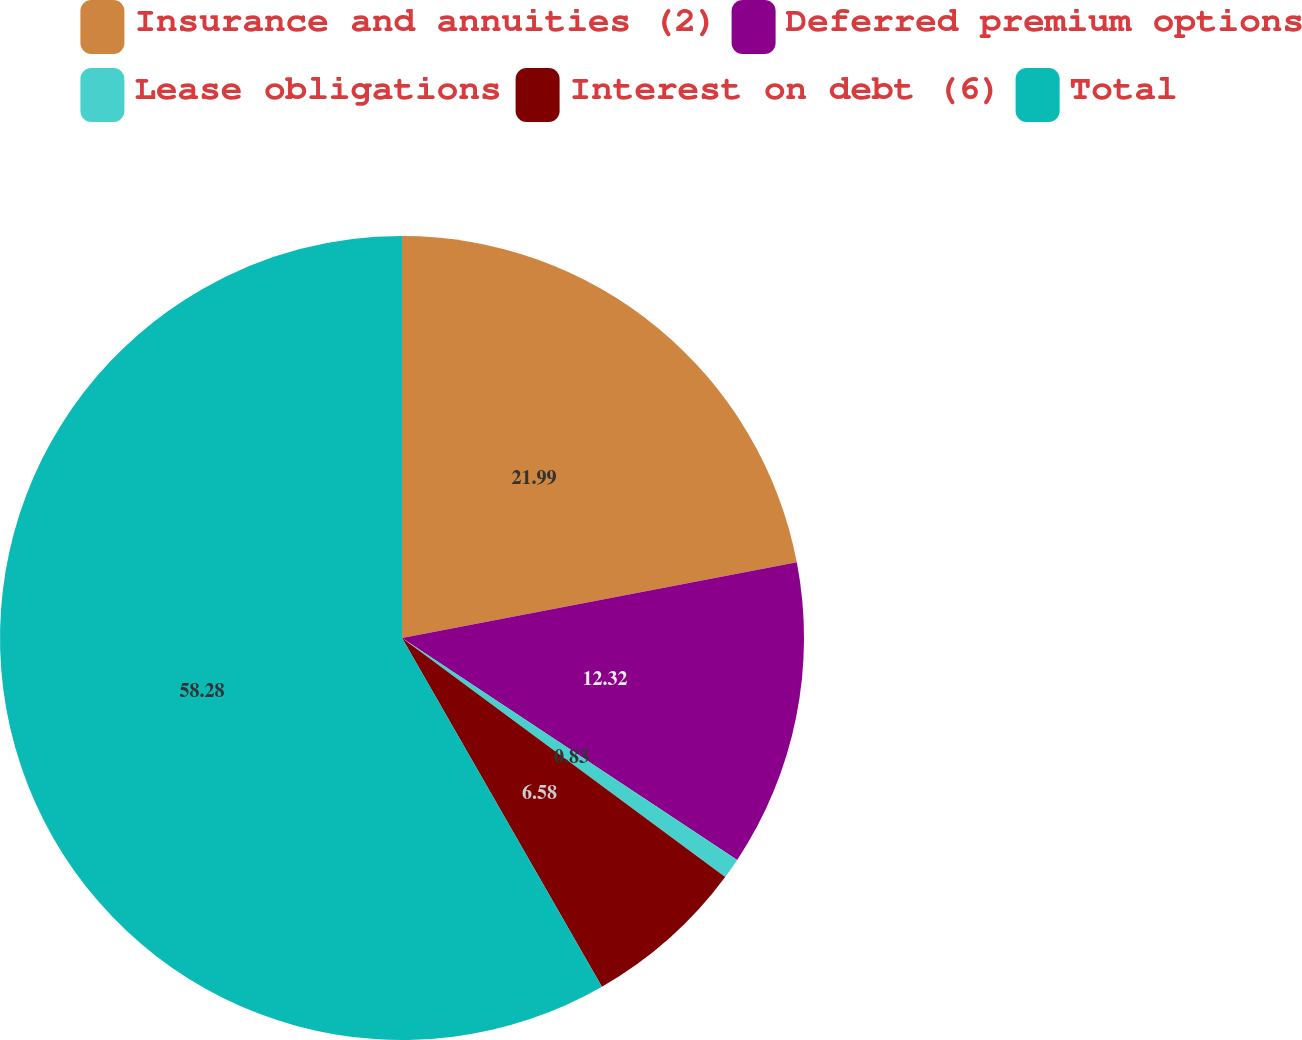Convert chart. <chart><loc_0><loc_0><loc_500><loc_500><pie_chart><fcel>Insurance and annuities (2)<fcel>Deferred premium options<fcel>Lease obligations<fcel>Interest on debt (6)<fcel>Total<nl><fcel>21.99%<fcel>12.32%<fcel>0.83%<fcel>6.58%<fcel>58.29%<nl></chart> 